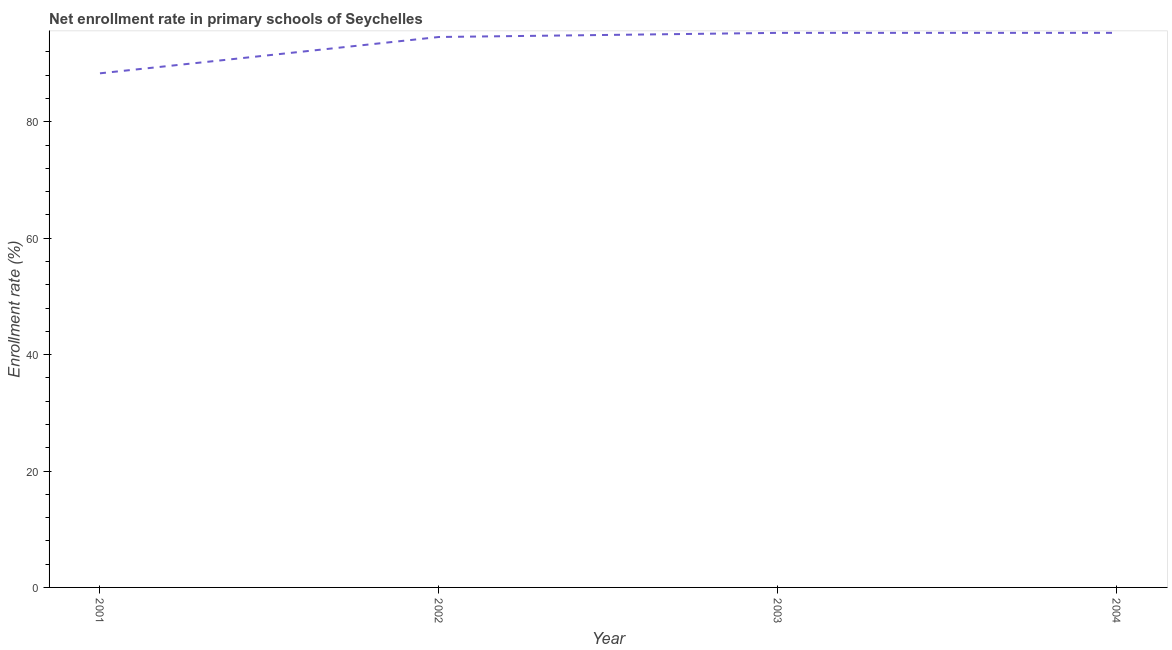What is the net enrollment rate in primary schools in 2001?
Offer a terse response. 88.32. Across all years, what is the maximum net enrollment rate in primary schools?
Ensure brevity in your answer.  95.28. Across all years, what is the minimum net enrollment rate in primary schools?
Provide a short and direct response. 88.32. In which year was the net enrollment rate in primary schools maximum?
Keep it short and to the point. 2004. What is the sum of the net enrollment rate in primary schools?
Your answer should be compact. 373.44. What is the difference between the net enrollment rate in primary schools in 2002 and 2004?
Offer a very short reply. -0.71. What is the average net enrollment rate in primary schools per year?
Provide a short and direct response. 93.36. What is the median net enrollment rate in primary schools?
Your answer should be very brief. 94.92. In how many years, is the net enrollment rate in primary schools greater than 8 %?
Your answer should be very brief. 4. Do a majority of the years between 2004 and 2003 (inclusive) have net enrollment rate in primary schools greater than 28 %?
Make the answer very short. No. What is the ratio of the net enrollment rate in primary schools in 2001 to that in 2002?
Your answer should be very brief. 0.93. Is the net enrollment rate in primary schools in 2001 less than that in 2002?
Provide a succinct answer. Yes. Is the difference between the net enrollment rate in primary schools in 2001 and 2004 greater than the difference between any two years?
Provide a succinct answer. Yes. What is the difference between the highest and the second highest net enrollment rate in primary schools?
Give a very brief answer. 0. Is the sum of the net enrollment rate in primary schools in 2002 and 2003 greater than the maximum net enrollment rate in primary schools across all years?
Give a very brief answer. Yes. What is the difference between the highest and the lowest net enrollment rate in primary schools?
Make the answer very short. 6.95. In how many years, is the net enrollment rate in primary schools greater than the average net enrollment rate in primary schools taken over all years?
Offer a terse response. 3. How many lines are there?
Keep it short and to the point. 1. How many years are there in the graph?
Offer a terse response. 4. Are the values on the major ticks of Y-axis written in scientific E-notation?
Give a very brief answer. No. Does the graph contain any zero values?
Your response must be concise. No. What is the title of the graph?
Give a very brief answer. Net enrollment rate in primary schools of Seychelles. What is the label or title of the X-axis?
Provide a short and direct response. Year. What is the label or title of the Y-axis?
Ensure brevity in your answer.  Enrollment rate (%). What is the Enrollment rate (%) in 2001?
Your answer should be compact. 88.32. What is the Enrollment rate (%) of 2002?
Offer a very short reply. 94.56. What is the Enrollment rate (%) of 2003?
Keep it short and to the point. 95.27. What is the Enrollment rate (%) in 2004?
Your response must be concise. 95.28. What is the difference between the Enrollment rate (%) in 2001 and 2002?
Keep it short and to the point. -6.24. What is the difference between the Enrollment rate (%) in 2001 and 2003?
Make the answer very short. -6.95. What is the difference between the Enrollment rate (%) in 2001 and 2004?
Ensure brevity in your answer.  -6.95. What is the difference between the Enrollment rate (%) in 2002 and 2003?
Your answer should be compact. -0.71. What is the difference between the Enrollment rate (%) in 2002 and 2004?
Keep it short and to the point. -0.71. What is the difference between the Enrollment rate (%) in 2003 and 2004?
Provide a short and direct response. -0. What is the ratio of the Enrollment rate (%) in 2001 to that in 2002?
Offer a terse response. 0.93. What is the ratio of the Enrollment rate (%) in 2001 to that in 2003?
Provide a succinct answer. 0.93. What is the ratio of the Enrollment rate (%) in 2001 to that in 2004?
Provide a short and direct response. 0.93. What is the ratio of the Enrollment rate (%) in 2002 to that in 2004?
Your answer should be compact. 0.99. 